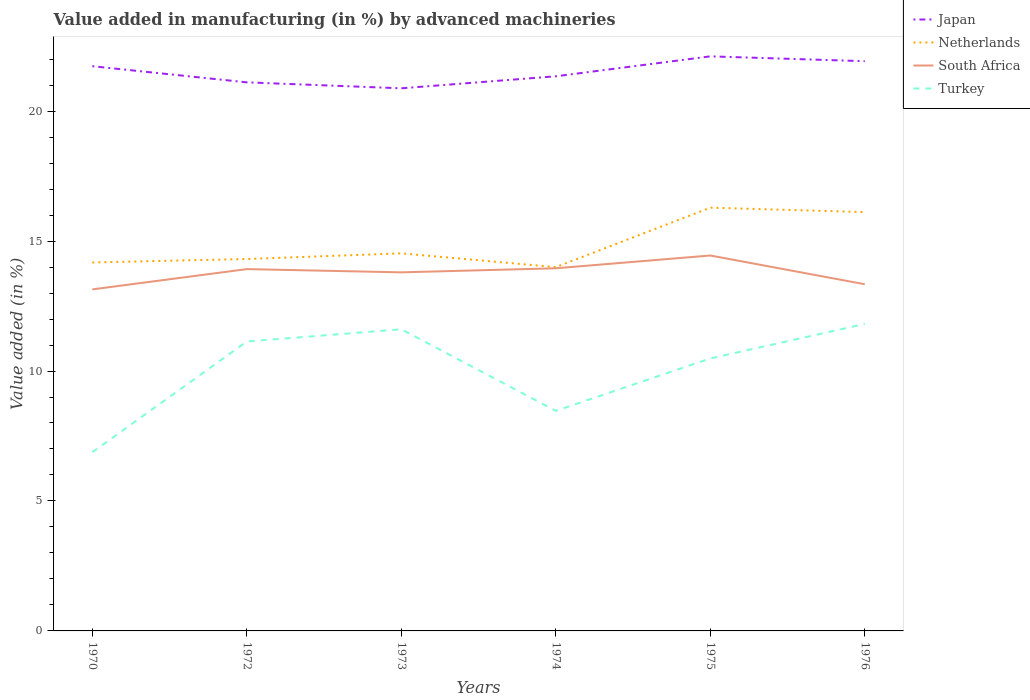How many different coloured lines are there?
Make the answer very short. 4. Is the number of lines equal to the number of legend labels?
Make the answer very short. Yes. Across all years, what is the maximum percentage of value added in manufacturing by advanced machineries in Japan?
Provide a succinct answer. 20.88. What is the total percentage of value added in manufacturing by advanced machineries in Turkey in the graph?
Offer a very short reply. -3.34. What is the difference between the highest and the second highest percentage of value added in manufacturing by advanced machineries in South Africa?
Provide a short and direct response. 1.3. What is the difference between the highest and the lowest percentage of value added in manufacturing by advanced machineries in Japan?
Provide a succinct answer. 3. How many lines are there?
Give a very brief answer. 4. How many years are there in the graph?
Provide a succinct answer. 6. Does the graph contain any zero values?
Ensure brevity in your answer.  No. Where does the legend appear in the graph?
Your answer should be compact. Top right. How many legend labels are there?
Provide a succinct answer. 4. How are the legend labels stacked?
Provide a succinct answer. Vertical. What is the title of the graph?
Give a very brief answer. Value added in manufacturing (in %) by advanced machineries. Does "Faeroe Islands" appear as one of the legend labels in the graph?
Offer a terse response. No. What is the label or title of the Y-axis?
Provide a succinct answer. Value added (in %). What is the Value added (in %) in Japan in 1970?
Keep it short and to the point. 21.73. What is the Value added (in %) of Netherlands in 1970?
Provide a succinct answer. 14.18. What is the Value added (in %) in South Africa in 1970?
Offer a terse response. 13.14. What is the Value added (in %) in Turkey in 1970?
Your response must be concise. 6.88. What is the Value added (in %) in Japan in 1972?
Offer a terse response. 21.11. What is the Value added (in %) of Netherlands in 1972?
Offer a terse response. 14.31. What is the Value added (in %) in South Africa in 1972?
Offer a terse response. 13.92. What is the Value added (in %) of Turkey in 1972?
Give a very brief answer. 11.14. What is the Value added (in %) of Japan in 1973?
Make the answer very short. 20.88. What is the Value added (in %) of Netherlands in 1973?
Make the answer very short. 14.53. What is the Value added (in %) in South Africa in 1973?
Your response must be concise. 13.8. What is the Value added (in %) of Turkey in 1973?
Give a very brief answer. 11.61. What is the Value added (in %) of Japan in 1974?
Provide a succinct answer. 21.34. What is the Value added (in %) in Netherlands in 1974?
Provide a succinct answer. 14. What is the Value added (in %) in South Africa in 1974?
Provide a short and direct response. 13.95. What is the Value added (in %) of Turkey in 1974?
Your response must be concise. 8.47. What is the Value added (in %) in Japan in 1975?
Give a very brief answer. 22.11. What is the Value added (in %) in Netherlands in 1975?
Provide a short and direct response. 16.28. What is the Value added (in %) of South Africa in 1975?
Offer a very short reply. 14.44. What is the Value added (in %) in Turkey in 1975?
Make the answer very short. 10.48. What is the Value added (in %) in Japan in 1976?
Your answer should be very brief. 21.92. What is the Value added (in %) of Netherlands in 1976?
Provide a short and direct response. 16.11. What is the Value added (in %) in South Africa in 1976?
Offer a very short reply. 13.34. What is the Value added (in %) in Turkey in 1976?
Your answer should be very brief. 11.81. Across all years, what is the maximum Value added (in %) of Japan?
Keep it short and to the point. 22.11. Across all years, what is the maximum Value added (in %) in Netherlands?
Ensure brevity in your answer.  16.28. Across all years, what is the maximum Value added (in %) of South Africa?
Make the answer very short. 14.44. Across all years, what is the maximum Value added (in %) of Turkey?
Offer a very short reply. 11.81. Across all years, what is the minimum Value added (in %) in Japan?
Make the answer very short. 20.88. Across all years, what is the minimum Value added (in %) of Netherlands?
Ensure brevity in your answer.  14. Across all years, what is the minimum Value added (in %) in South Africa?
Provide a short and direct response. 13.14. Across all years, what is the minimum Value added (in %) in Turkey?
Keep it short and to the point. 6.88. What is the total Value added (in %) in Japan in the graph?
Your answer should be very brief. 129.08. What is the total Value added (in %) in Netherlands in the graph?
Provide a short and direct response. 89.41. What is the total Value added (in %) in South Africa in the graph?
Your answer should be compact. 82.59. What is the total Value added (in %) of Turkey in the graph?
Offer a very short reply. 60.38. What is the difference between the Value added (in %) in Japan in 1970 and that in 1972?
Ensure brevity in your answer.  0.62. What is the difference between the Value added (in %) in Netherlands in 1970 and that in 1972?
Offer a terse response. -0.13. What is the difference between the Value added (in %) of South Africa in 1970 and that in 1972?
Your response must be concise. -0.78. What is the difference between the Value added (in %) of Turkey in 1970 and that in 1972?
Your answer should be very brief. -4.26. What is the difference between the Value added (in %) in Japan in 1970 and that in 1973?
Make the answer very short. 0.85. What is the difference between the Value added (in %) in Netherlands in 1970 and that in 1973?
Your response must be concise. -0.35. What is the difference between the Value added (in %) of South Africa in 1970 and that in 1973?
Provide a succinct answer. -0.66. What is the difference between the Value added (in %) of Turkey in 1970 and that in 1973?
Offer a very short reply. -4.73. What is the difference between the Value added (in %) of Japan in 1970 and that in 1974?
Give a very brief answer. 0.39. What is the difference between the Value added (in %) in Netherlands in 1970 and that in 1974?
Offer a terse response. 0.18. What is the difference between the Value added (in %) in South Africa in 1970 and that in 1974?
Give a very brief answer. -0.81. What is the difference between the Value added (in %) of Turkey in 1970 and that in 1974?
Ensure brevity in your answer.  -1.59. What is the difference between the Value added (in %) of Japan in 1970 and that in 1975?
Offer a very short reply. -0.38. What is the difference between the Value added (in %) of Netherlands in 1970 and that in 1975?
Provide a short and direct response. -2.11. What is the difference between the Value added (in %) of South Africa in 1970 and that in 1975?
Ensure brevity in your answer.  -1.3. What is the difference between the Value added (in %) of Turkey in 1970 and that in 1975?
Ensure brevity in your answer.  -3.61. What is the difference between the Value added (in %) of Japan in 1970 and that in 1976?
Your response must be concise. -0.19. What is the difference between the Value added (in %) of Netherlands in 1970 and that in 1976?
Ensure brevity in your answer.  -1.94. What is the difference between the Value added (in %) in South Africa in 1970 and that in 1976?
Provide a succinct answer. -0.2. What is the difference between the Value added (in %) in Turkey in 1970 and that in 1976?
Offer a very short reply. -4.93. What is the difference between the Value added (in %) in Japan in 1972 and that in 1973?
Ensure brevity in your answer.  0.23. What is the difference between the Value added (in %) of Netherlands in 1972 and that in 1973?
Your response must be concise. -0.22. What is the difference between the Value added (in %) of South Africa in 1972 and that in 1973?
Offer a very short reply. 0.12. What is the difference between the Value added (in %) in Turkey in 1972 and that in 1973?
Your response must be concise. -0.47. What is the difference between the Value added (in %) of Japan in 1972 and that in 1974?
Provide a short and direct response. -0.23. What is the difference between the Value added (in %) of Netherlands in 1972 and that in 1974?
Make the answer very short. 0.31. What is the difference between the Value added (in %) in South Africa in 1972 and that in 1974?
Provide a short and direct response. -0.03. What is the difference between the Value added (in %) in Turkey in 1972 and that in 1974?
Your answer should be compact. 2.67. What is the difference between the Value added (in %) of Japan in 1972 and that in 1975?
Provide a succinct answer. -1. What is the difference between the Value added (in %) of Netherlands in 1972 and that in 1975?
Your response must be concise. -1.97. What is the difference between the Value added (in %) in South Africa in 1972 and that in 1975?
Your response must be concise. -0.52. What is the difference between the Value added (in %) of Turkey in 1972 and that in 1975?
Offer a terse response. 0.65. What is the difference between the Value added (in %) in Japan in 1972 and that in 1976?
Your response must be concise. -0.81. What is the difference between the Value added (in %) of Netherlands in 1972 and that in 1976?
Offer a very short reply. -1.8. What is the difference between the Value added (in %) of South Africa in 1972 and that in 1976?
Give a very brief answer. 0.58. What is the difference between the Value added (in %) of Turkey in 1972 and that in 1976?
Offer a terse response. -0.67. What is the difference between the Value added (in %) in Japan in 1973 and that in 1974?
Provide a short and direct response. -0.46. What is the difference between the Value added (in %) of Netherlands in 1973 and that in 1974?
Ensure brevity in your answer.  0.53. What is the difference between the Value added (in %) of South Africa in 1973 and that in 1974?
Your response must be concise. -0.16. What is the difference between the Value added (in %) in Turkey in 1973 and that in 1974?
Provide a succinct answer. 3.14. What is the difference between the Value added (in %) in Japan in 1973 and that in 1975?
Give a very brief answer. -1.23. What is the difference between the Value added (in %) of Netherlands in 1973 and that in 1975?
Keep it short and to the point. -1.76. What is the difference between the Value added (in %) in South Africa in 1973 and that in 1975?
Your answer should be very brief. -0.65. What is the difference between the Value added (in %) in Turkey in 1973 and that in 1975?
Keep it short and to the point. 1.12. What is the difference between the Value added (in %) in Japan in 1973 and that in 1976?
Your response must be concise. -1.04. What is the difference between the Value added (in %) of Netherlands in 1973 and that in 1976?
Give a very brief answer. -1.59. What is the difference between the Value added (in %) of South Africa in 1973 and that in 1976?
Give a very brief answer. 0.46. What is the difference between the Value added (in %) in Turkey in 1973 and that in 1976?
Provide a short and direct response. -0.2. What is the difference between the Value added (in %) of Japan in 1974 and that in 1975?
Your response must be concise. -0.77. What is the difference between the Value added (in %) of Netherlands in 1974 and that in 1975?
Give a very brief answer. -2.29. What is the difference between the Value added (in %) of South Africa in 1974 and that in 1975?
Provide a short and direct response. -0.49. What is the difference between the Value added (in %) of Turkey in 1974 and that in 1975?
Offer a terse response. -2.02. What is the difference between the Value added (in %) of Japan in 1974 and that in 1976?
Make the answer very short. -0.58. What is the difference between the Value added (in %) of Netherlands in 1974 and that in 1976?
Give a very brief answer. -2.12. What is the difference between the Value added (in %) of South Africa in 1974 and that in 1976?
Offer a terse response. 0.61. What is the difference between the Value added (in %) in Turkey in 1974 and that in 1976?
Provide a succinct answer. -3.34. What is the difference between the Value added (in %) of Japan in 1975 and that in 1976?
Your response must be concise. 0.19. What is the difference between the Value added (in %) of Netherlands in 1975 and that in 1976?
Ensure brevity in your answer.  0.17. What is the difference between the Value added (in %) of South Africa in 1975 and that in 1976?
Your answer should be very brief. 1.11. What is the difference between the Value added (in %) in Turkey in 1975 and that in 1976?
Provide a short and direct response. -1.33. What is the difference between the Value added (in %) in Japan in 1970 and the Value added (in %) in Netherlands in 1972?
Your answer should be very brief. 7.42. What is the difference between the Value added (in %) in Japan in 1970 and the Value added (in %) in South Africa in 1972?
Provide a short and direct response. 7.81. What is the difference between the Value added (in %) of Japan in 1970 and the Value added (in %) of Turkey in 1972?
Your answer should be compact. 10.59. What is the difference between the Value added (in %) in Netherlands in 1970 and the Value added (in %) in South Africa in 1972?
Your answer should be very brief. 0.26. What is the difference between the Value added (in %) in Netherlands in 1970 and the Value added (in %) in Turkey in 1972?
Offer a very short reply. 3.04. What is the difference between the Value added (in %) in South Africa in 1970 and the Value added (in %) in Turkey in 1972?
Your answer should be compact. 2. What is the difference between the Value added (in %) in Japan in 1970 and the Value added (in %) in Netherlands in 1973?
Offer a terse response. 7.2. What is the difference between the Value added (in %) of Japan in 1970 and the Value added (in %) of South Africa in 1973?
Keep it short and to the point. 7.93. What is the difference between the Value added (in %) of Japan in 1970 and the Value added (in %) of Turkey in 1973?
Give a very brief answer. 10.12. What is the difference between the Value added (in %) in Netherlands in 1970 and the Value added (in %) in South Africa in 1973?
Make the answer very short. 0.38. What is the difference between the Value added (in %) of Netherlands in 1970 and the Value added (in %) of Turkey in 1973?
Provide a succinct answer. 2.57. What is the difference between the Value added (in %) in South Africa in 1970 and the Value added (in %) in Turkey in 1973?
Your answer should be compact. 1.53. What is the difference between the Value added (in %) in Japan in 1970 and the Value added (in %) in Netherlands in 1974?
Your answer should be compact. 7.73. What is the difference between the Value added (in %) of Japan in 1970 and the Value added (in %) of South Africa in 1974?
Provide a short and direct response. 7.77. What is the difference between the Value added (in %) of Japan in 1970 and the Value added (in %) of Turkey in 1974?
Your response must be concise. 13.26. What is the difference between the Value added (in %) in Netherlands in 1970 and the Value added (in %) in South Africa in 1974?
Your response must be concise. 0.22. What is the difference between the Value added (in %) of Netherlands in 1970 and the Value added (in %) of Turkey in 1974?
Keep it short and to the point. 5.71. What is the difference between the Value added (in %) in South Africa in 1970 and the Value added (in %) in Turkey in 1974?
Give a very brief answer. 4.67. What is the difference between the Value added (in %) in Japan in 1970 and the Value added (in %) in Netherlands in 1975?
Provide a short and direct response. 5.44. What is the difference between the Value added (in %) of Japan in 1970 and the Value added (in %) of South Africa in 1975?
Offer a very short reply. 7.28. What is the difference between the Value added (in %) in Japan in 1970 and the Value added (in %) in Turkey in 1975?
Give a very brief answer. 11.24. What is the difference between the Value added (in %) in Netherlands in 1970 and the Value added (in %) in South Africa in 1975?
Your answer should be very brief. -0.27. What is the difference between the Value added (in %) of Netherlands in 1970 and the Value added (in %) of Turkey in 1975?
Your answer should be compact. 3.69. What is the difference between the Value added (in %) of South Africa in 1970 and the Value added (in %) of Turkey in 1975?
Ensure brevity in your answer.  2.66. What is the difference between the Value added (in %) in Japan in 1970 and the Value added (in %) in Netherlands in 1976?
Your response must be concise. 5.61. What is the difference between the Value added (in %) of Japan in 1970 and the Value added (in %) of South Africa in 1976?
Make the answer very short. 8.39. What is the difference between the Value added (in %) of Japan in 1970 and the Value added (in %) of Turkey in 1976?
Offer a very short reply. 9.92. What is the difference between the Value added (in %) of Netherlands in 1970 and the Value added (in %) of South Africa in 1976?
Your response must be concise. 0.84. What is the difference between the Value added (in %) of Netherlands in 1970 and the Value added (in %) of Turkey in 1976?
Offer a terse response. 2.37. What is the difference between the Value added (in %) of South Africa in 1970 and the Value added (in %) of Turkey in 1976?
Offer a terse response. 1.33. What is the difference between the Value added (in %) of Japan in 1972 and the Value added (in %) of Netherlands in 1973?
Ensure brevity in your answer.  6.58. What is the difference between the Value added (in %) of Japan in 1972 and the Value added (in %) of South Africa in 1973?
Your response must be concise. 7.31. What is the difference between the Value added (in %) in Japan in 1972 and the Value added (in %) in Turkey in 1973?
Your answer should be compact. 9.5. What is the difference between the Value added (in %) of Netherlands in 1972 and the Value added (in %) of South Africa in 1973?
Your response must be concise. 0.51. What is the difference between the Value added (in %) in Netherlands in 1972 and the Value added (in %) in Turkey in 1973?
Keep it short and to the point. 2.7. What is the difference between the Value added (in %) in South Africa in 1972 and the Value added (in %) in Turkey in 1973?
Offer a terse response. 2.31. What is the difference between the Value added (in %) of Japan in 1972 and the Value added (in %) of Netherlands in 1974?
Offer a very short reply. 7.11. What is the difference between the Value added (in %) of Japan in 1972 and the Value added (in %) of South Africa in 1974?
Ensure brevity in your answer.  7.15. What is the difference between the Value added (in %) of Japan in 1972 and the Value added (in %) of Turkey in 1974?
Your response must be concise. 12.64. What is the difference between the Value added (in %) in Netherlands in 1972 and the Value added (in %) in South Africa in 1974?
Provide a succinct answer. 0.36. What is the difference between the Value added (in %) in Netherlands in 1972 and the Value added (in %) in Turkey in 1974?
Provide a short and direct response. 5.84. What is the difference between the Value added (in %) of South Africa in 1972 and the Value added (in %) of Turkey in 1974?
Offer a terse response. 5.45. What is the difference between the Value added (in %) of Japan in 1972 and the Value added (in %) of Netherlands in 1975?
Make the answer very short. 4.82. What is the difference between the Value added (in %) of Japan in 1972 and the Value added (in %) of South Africa in 1975?
Offer a very short reply. 6.66. What is the difference between the Value added (in %) in Japan in 1972 and the Value added (in %) in Turkey in 1975?
Keep it short and to the point. 10.62. What is the difference between the Value added (in %) of Netherlands in 1972 and the Value added (in %) of South Africa in 1975?
Provide a short and direct response. -0.13. What is the difference between the Value added (in %) of Netherlands in 1972 and the Value added (in %) of Turkey in 1975?
Offer a terse response. 3.83. What is the difference between the Value added (in %) of South Africa in 1972 and the Value added (in %) of Turkey in 1975?
Your answer should be very brief. 3.44. What is the difference between the Value added (in %) in Japan in 1972 and the Value added (in %) in Netherlands in 1976?
Provide a succinct answer. 4.99. What is the difference between the Value added (in %) of Japan in 1972 and the Value added (in %) of South Africa in 1976?
Provide a succinct answer. 7.77. What is the difference between the Value added (in %) in Japan in 1972 and the Value added (in %) in Turkey in 1976?
Offer a very short reply. 9.3. What is the difference between the Value added (in %) in Netherlands in 1972 and the Value added (in %) in South Africa in 1976?
Your answer should be compact. 0.97. What is the difference between the Value added (in %) in Netherlands in 1972 and the Value added (in %) in Turkey in 1976?
Your response must be concise. 2.5. What is the difference between the Value added (in %) in South Africa in 1972 and the Value added (in %) in Turkey in 1976?
Your answer should be very brief. 2.11. What is the difference between the Value added (in %) of Japan in 1973 and the Value added (in %) of Netherlands in 1974?
Your answer should be compact. 6.88. What is the difference between the Value added (in %) in Japan in 1973 and the Value added (in %) in South Africa in 1974?
Offer a terse response. 6.92. What is the difference between the Value added (in %) of Japan in 1973 and the Value added (in %) of Turkey in 1974?
Your answer should be compact. 12.41. What is the difference between the Value added (in %) of Netherlands in 1973 and the Value added (in %) of South Africa in 1974?
Keep it short and to the point. 0.57. What is the difference between the Value added (in %) in Netherlands in 1973 and the Value added (in %) in Turkey in 1974?
Ensure brevity in your answer.  6.06. What is the difference between the Value added (in %) in South Africa in 1973 and the Value added (in %) in Turkey in 1974?
Your response must be concise. 5.33. What is the difference between the Value added (in %) of Japan in 1973 and the Value added (in %) of Netherlands in 1975?
Your response must be concise. 4.59. What is the difference between the Value added (in %) of Japan in 1973 and the Value added (in %) of South Africa in 1975?
Ensure brevity in your answer.  6.43. What is the difference between the Value added (in %) of Japan in 1973 and the Value added (in %) of Turkey in 1975?
Keep it short and to the point. 10.39. What is the difference between the Value added (in %) in Netherlands in 1973 and the Value added (in %) in South Africa in 1975?
Ensure brevity in your answer.  0.08. What is the difference between the Value added (in %) in Netherlands in 1973 and the Value added (in %) in Turkey in 1975?
Ensure brevity in your answer.  4.04. What is the difference between the Value added (in %) in South Africa in 1973 and the Value added (in %) in Turkey in 1975?
Provide a succinct answer. 3.31. What is the difference between the Value added (in %) of Japan in 1973 and the Value added (in %) of Netherlands in 1976?
Offer a terse response. 4.76. What is the difference between the Value added (in %) of Japan in 1973 and the Value added (in %) of South Africa in 1976?
Ensure brevity in your answer.  7.54. What is the difference between the Value added (in %) of Japan in 1973 and the Value added (in %) of Turkey in 1976?
Give a very brief answer. 9.07. What is the difference between the Value added (in %) of Netherlands in 1973 and the Value added (in %) of South Africa in 1976?
Provide a succinct answer. 1.19. What is the difference between the Value added (in %) of Netherlands in 1973 and the Value added (in %) of Turkey in 1976?
Keep it short and to the point. 2.72. What is the difference between the Value added (in %) of South Africa in 1973 and the Value added (in %) of Turkey in 1976?
Make the answer very short. 1.99. What is the difference between the Value added (in %) in Japan in 1974 and the Value added (in %) in Netherlands in 1975?
Your response must be concise. 5.06. What is the difference between the Value added (in %) in Japan in 1974 and the Value added (in %) in South Africa in 1975?
Your response must be concise. 6.9. What is the difference between the Value added (in %) of Japan in 1974 and the Value added (in %) of Turkey in 1975?
Make the answer very short. 10.86. What is the difference between the Value added (in %) in Netherlands in 1974 and the Value added (in %) in South Africa in 1975?
Your response must be concise. -0.45. What is the difference between the Value added (in %) of Netherlands in 1974 and the Value added (in %) of Turkey in 1975?
Offer a very short reply. 3.51. What is the difference between the Value added (in %) in South Africa in 1974 and the Value added (in %) in Turkey in 1975?
Ensure brevity in your answer.  3.47. What is the difference between the Value added (in %) in Japan in 1974 and the Value added (in %) in Netherlands in 1976?
Offer a very short reply. 5.23. What is the difference between the Value added (in %) in Japan in 1974 and the Value added (in %) in South Africa in 1976?
Make the answer very short. 8. What is the difference between the Value added (in %) of Japan in 1974 and the Value added (in %) of Turkey in 1976?
Provide a short and direct response. 9.53. What is the difference between the Value added (in %) in Netherlands in 1974 and the Value added (in %) in South Africa in 1976?
Provide a succinct answer. 0.66. What is the difference between the Value added (in %) of Netherlands in 1974 and the Value added (in %) of Turkey in 1976?
Provide a succinct answer. 2.19. What is the difference between the Value added (in %) in South Africa in 1974 and the Value added (in %) in Turkey in 1976?
Ensure brevity in your answer.  2.14. What is the difference between the Value added (in %) of Japan in 1975 and the Value added (in %) of Netherlands in 1976?
Your response must be concise. 5.99. What is the difference between the Value added (in %) of Japan in 1975 and the Value added (in %) of South Africa in 1976?
Provide a short and direct response. 8.77. What is the difference between the Value added (in %) in Japan in 1975 and the Value added (in %) in Turkey in 1976?
Your response must be concise. 10.3. What is the difference between the Value added (in %) in Netherlands in 1975 and the Value added (in %) in South Africa in 1976?
Offer a very short reply. 2.95. What is the difference between the Value added (in %) in Netherlands in 1975 and the Value added (in %) in Turkey in 1976?
Make the answer very short. 4.47. What is the difference between the Value added (in %) in South Africa in 1975 and the Value added (in %) in Turkey in 1976?
Provide a succinct answer. 2.63. What is the average Value added (in %) in Japan per year?
Your response must be concise. 21.51. What is the average Value added (in %) in Netherlands per year?
Your answer should be compact. 14.9. What is the average Value added (in %) in South Africa per year?
Your answer should be compact. 13.77. What is the average Value added (in %) in Turkey per year?
Provide a succinct answer. 10.06. In the year 1970, what is the difference between the Value added (in %) in Japan and Value added (in %) in Netherlands?
Offer a terse response. 7.55. In the year 1970, what is the difference between the Value added (in %) of Japan and Value added (in %) of South Africa?
Your response must be concise. 8.59. In the year 1970, what is the difference between the Value added (in %) in Japan and Value added (in %) in Turkey?
Your response must be concise. 14.85. In the year 1970, what is the difference between the Value added (in %) in Netherlands and Value added (in %) in South Africa?
Your answer should be compact. 1.04. In the year 1970, what is the difference between the Value added (in %) in Netherlands and Value added (in %) in Turkey?
Provide a succinct answer. 7.3. In the year 1970, what is the difference between the Value added (in %) in South Africa and Value added (in %) in Turkey?
Ensure brevity in your answer.  6.26. In the year 1972, what is the difference between the Value added (in %) in Japan and Value added (in %) in Netherlands?
Ensure brevity in your answer.  6.8. In the year 1972, what is the difference between the Value added (in %) of Japan and Value added (in %) of South Africa?
Offer a very short reply. 7.19. In the year 1972, what is the difference between the Value added (in %) of Japan and Value added (in %) of Turkey?
Provide a short and direct response. 9.97. In the year 1972, what is the difference between the Value added (in %) of Netherlands and Value added (in %) of South Africa?
Your answer should be very brief. 0.39. In the year 1972, what is the difference between the Value added (in %) in Netherlands and Value added (in %) in Turkey?
Provide a short and direct response. 3.17. In the year 1972, what is the difference between the Value added (in %) of South Africa and Value added (in %) of Turkey?
Your answer should be compact. 2.78. In the year 1973, what is the difference between the Value added (in %) in Japan and Value added (in %) in Netherlands?
Provide a short and direct response. 6.35. In the year 1973, what is the difference between the Value added (in %) of Japan and Value added (in %) of South Africa?
Your answer should be compact. 7.08. In the year 1973, what is the difference between the Value added (in %) in Japan and Value added (in %) in Turkey?
Keep it short and to the point. 9.27. In the year 1973, what is the difference between the Value added (in %) in Netherlands and Value added (in %) in South Africa?
Provide a succinct answer. 0.73. In the year 1973, what is the difference between the Value added (in %) of Netherlands and Value added (in %) of Turkey?
Your answer should be compact. 2.92. In the year 1973, what is the difference between the Value added (in %) in South Africa and Value added (in %) in Turkey?
Keep it short and to the point. 2.19. In the year 1974, what is the difference between the Value added (in %) in Japan and Value added (in %) in Netherlands?
Give a very brief answer. 7.34. In the year 1974, what is the difference between the Value added (in %) in Japan and Value added (in %) in South Africa?
Offer a terse response. 7.39. In the year 1974, what is the difference between the Value added (in %) in Japan and Value added (in %) in Turkey?
Offer a terse response. 12.87. In the year 1974, what is the difference between the Value added (in %) in Netherlands and Value added (in %) in South Africa?
Offer a terse response. 0.04. In the year 1974, what is the difference between the Value added (in %) in Netherlands and Value added (in %) in Turkey?
Offer a terse response. 5.53. In the year 1974, what is the difference between the Value added (in %) in South Africa and Value added (in %) in Turkey?
Provide a succinct answer. 5.49. In the year 1975, what is the difference between the Value added (in %) of Japan and Value added (in %) of Netherlands?
Provide a succinct answer. 5.82. In the year 1975, what is the difference between the Value added (in %) in Japan and Value added (in %) in South Africa?
Offer a terse response. 7.66. In the year 1975, what is the difference between the Value added (in %) in Japan and Value added (in %) in Turkey?
Provide a succinct answer. 11.62. In the year 1975, what is the difference between the Value added (in %) of Netherlands and Value added (in %) of South Africa?
Ensure brevity in your answer.  1.84. In the year 1975, what is the difference between the Value added (in %) in Netherlands and Value added (in %) in Turkey?
Your answer should be very brief. 5.8. In the year 1975, what is the difference between the Value added (in %) in South Africa and Value added (in %) in Turkey?
Ensure brevity in your answer.  3.96. In the year 1976, what is the difference between the Value added (in %) of Japan and Value added (in %) of Netherlands?
Offer a very short reply. 5.81. In the year 1976, what is the difference between the Value added (in %) in Japan and Value added (in %) in South Africa?
Provide a short and direct response. 8.58. In the year 1976, what is the difference between the Value added (in %) of Japan and Value added (in %) of Turkey?
Offer a terse response. 10.11. In the year 1976, what is the difference between the Value added (in %) in Netherlands and Value added (in %) in South Africa?
Provide a succinct answer. 2.78. In the year 1976, what is the difference between the Value added (in %) of Netherlands and Value added (in %) of Turkey?
Your response must be concise. 4.3. In the year 1976, what is the difference between the Value added (in %) in South Africa and Value added (in %) in Turkey?
Provide a succinct answer. 1.53. What is the ratio of the Value added (in %) of Japan in 1970 to that in 1972?
Ensure brevity in your answer.  1.03. What is the ratio of the Value added (in %) in Netherlands in 1970 to that in 1972?
Make the answer very short. 0.99. What is the ratio of the Value added (in %) in South Africa in 1970 to that in 1972?
Provide a short and direct response. 0.94. What is the ratio of the Value added (in %) in Turkey in 1970 to that in 1972?
Your answer should be compact. 0.62. What is the ratio of the Value added (in %) of Japan in 1970 to that in 1973?
Make the answer very short. 1.04. What is the ratio of the Value added (in %) in Netherlands in 1970 to that in 1973?
Offer a very short reply. 0.98. What is the ratio of the Value added (in %) of South Africa in 1970 to that in 1973?
Your response must be concise. 0.95. What is the ratio of the Value added (in %) of Turkey in 1970 to that in 1973?
Provide a succinct answer. 0.59. What is the ratio of the Value added (in %) in Japan in 1970 to that in 1974?
Offer a terse response. 1.02. What is the ratio of the Value added (in %) in Netherlands in 1970 to that in 1974?
Make the answer very short. 1.01. What is the ratio of the Value added (in %) in South Africa in 1970 to that in 1974?
Provide a short and direct response. 0.94. What is the ratio of the Value added (in %) in Turkey in 1970 to that in 1974?
Your response must be concise. 0.81. What is the ratio of the Value added (in %) in Japan in 1970 to that in 1975?
Your response must be concise. 0.98. What is the ratio of the Value added (in %) of Netherlands in 1970 to that in 1975?
Offer a very short reply. 0.87. What is the ratio of the Value added (in %) in South Africa in 1970 to that in 1975?
Offer a very short reply. 0.91. What is the ratio of the Value added (in %) of Turkey in 1970 to that in 1975?
Offer a very short reply. 0.66. What is the ratio of the Value added (in %) of Japan in 1970 to that in 1976?
Provide a succinct answer. 0.99. What is the ratio of the Value added (in %) in Netherlands in 1970 to that in 1976?
Make the answer very short. 0.88. What is the ratio of the Value added (in %) in South Africa in 1970 to that in 1976?
Provide a short and direct response. 0.99. What is the ratio of the Value added (in %) of Turkey in 1970 to that in 1976?
Offer a very short reply. 0.58. What is the ratio of the Value added (in %) in Netherlands in 1972 to that in 1973?
Your answer should be very brief. 0.99. What is the ratio of the Value added (in %) in Turkey in 1972 to that in 1973?
Give a very brief answer. 0.96. What is the ratio of the Value added (in %) of Netherlands in 1972 to that in 1974?
Provide a short and direct response. 1.02. What is the ratio of the Value added (in %) in South Africa in 1972 to that in 1974?
Your answer should be very brief. 1. What is the ratio of the Value added (in %) of Turkey in 1972 to that in 1974?
Provide a succinct answer. 1.32. What is the ratio of the Value added (in %) of Japan in 1972 to that in 1975?
Your response must be concise. 0.95. What is the ratio of the Value added (in %) of Netherlands in 1972 to that in 1975?
Offer a very short reply. 0.88. What is the ratio of the Value added (in %) of South Africa in 1972 to that in 1975?
Make the answer very short. 0.96. What is the ratio of the Value added (in %) of Turkey in 1972 to that in 1975?
Make the answer very short. 1.06. What is the ratio of the Value added (in %) of Japan in 1972 to that in 1976?
Offer a terse response. 0.96. What is the ratio of the Value added (in %) in Netherlands in 1972 to that in 1976?
Your answer should be very brief. 0.89. What is the ratio of the Value added (in %) of South Africa in 1972 to that in 1976?
Make the answer very short. 1.04. What is the ratio of the Value added (in %) of Turkey in 1972 to that in 1976?
Your answer should be very brief. 0.94. What is the ratio of the Value added (in %) in Japan in 1973 to that in 1974?
Provide a succinct answer. 0.98. What is the ratio of the Value added (in %) of Netherlands in 1973 to that in 1974?
Provide a short and direct response. 1.04. What is the ratio of the Value added (in %) of South Africa in 1973 to that in 1974?
Provide a short and direct response. 0.99. What is the ratio of the Value added (in %) of Turkey in 1973 to that in 1974?
Your answer should be very brief. 1.37. What is the ratio of the Value added (in %) of Japan in 1973 to that in 1975?
Ensure brevity in your answer.  0.94. What is the ratio of the Value added (in %) of Netherlands in 1973 to that in 1975?
Ensure brevity in your answer.  0.89. What is the ratio of the Value added (in %) in South Africa in 1973 to that in 1975?
Your answer should be compact. 0.96. What is the ratio of the Value added (in %) of Turkey in 1973 to that in 1975?
Ensure brevity in your answer.  1.11. What is the ratio of the Value added (in %) in Netherlands in 1973 to that in 1976?
Make the answer very short. 0.9. What is the ratio of the Value added (in %) in South Africa in 1973 to that in 1976?
Ensure brevity in your answer.  1.03. What is the ratio of the Value added (in %) in Turkey in 1973 to that in 1976?
Provide a short and direct response. 0.98. What is the ratio of the Value added (in %) of Japan in 1974 to that in 1975?
Provide a succinct answer. 0.97. What is the ratio of the Value added (in %) in Netherlands in 1974 to that in 1975?
Your answer should be compact. 0.86. What is the ratio of the Value added (in %) of South Africa in 1974 to that in 1975?
Ensure brevity in your answer.  0.97. What is the ratio of the Value added (in %) of Turkey in 1974 to that in 1975?
Your answer should be very brief. 0.81. What is the ratio of the Value added (in %) of Japan in 1974 to that in 1976?
Provide a succinct answer. 0.97. What is the ratio of the Value added (in %) of Netherlands in 1974 to that in 1976?
Give a very brief answer. 0.87. What is the ratio of the Value added (in %) of South Africa in 1974 to that in 1976?
Provide a succinct answer. 1.05. What is the ratio of the Value added (in %) in Turkey in 1974 to that in 1976?
Ensure brevity in your answer.  0.72. What is the ratio of the Value added (in %) in Japan in 1975 to that in 1976?
Your answer should be very brief. 1.01. What is the ratio of the Value added (in %) in Netherlands in 1975 to that in 1976?
Keep it short and to the point. 1.01. What is the ratio of the Value added (in %) of South Africa in 1975 to that in 1976?
Your response must be concise. 1.08. What is the ratio of the Value added (in %) in Turkey in 1975 to that in 1976?
Provide a short and direct response. 0.89. What is the difference between the highest and the second highest Value added (in %) of Japan?
Your answer should be very brief. 0.19. What is the difference between the highest and the second highest Value added (in %) in Netherlands?
Give a very brief answer. 0.17. What is the difference between the highest and the second highest Value added (in %) of South Africa?
Give a very brief answer. 0.49. What is the difference between the highest and the second highest Value added (in %) in Turkey?
Provide a short and direct response. 0.2. What is the difference between the highest and the lowest Value added (in %) of Japan?
Provide a succinct answer. 1.23. What is the difference between the highest and the lowest Value added (in %) in Netherlands?
Keep it short and to the point. 2.29. What is the difference between the highest and the lowest Value added (in %) of South Africa?
Offer a terse response. 1.3. What is the difference between the highest and the lowest Value added (in %) of Turkey?
Keep it short and to the point. 4.93. 